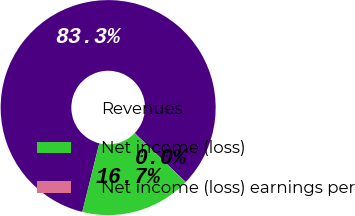Convert chart to OTSL. <chart><loc_0><loc_0><loc_500><loc_500><pie_chart><fcel>Revenues<fcel>Net income (loss)<fcel>Net income (loss) earnings per<nl><fcel>83.31%<fcel>16.67%<fcel>0.02%<nl></chart> 